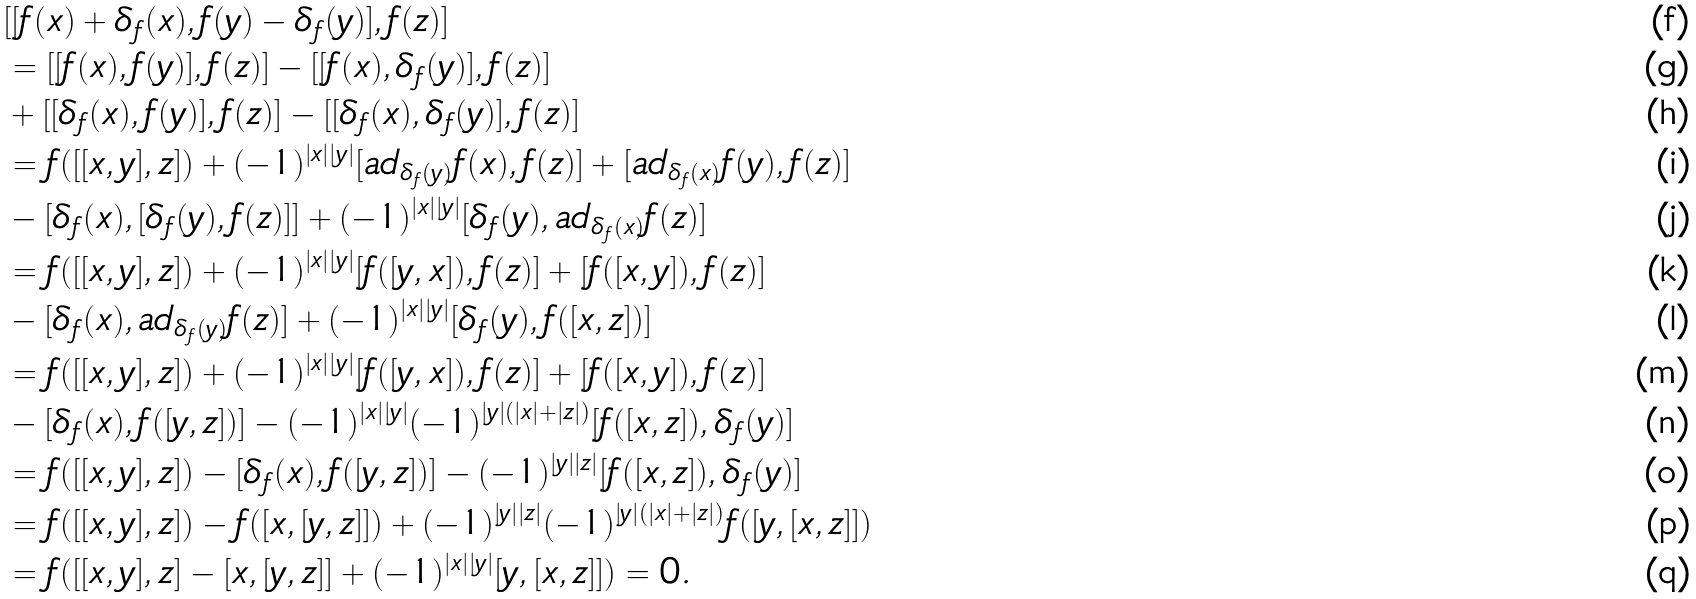<formula> <loc_0><loc_0><loc_500><loc_500>& [ [ f ( x ) + \delta _ { f } ( x ) , f ( y ) - \delta _ { f } ( y ) ] , f ( z ) ] \\ & = [ [ f ( x ) , f ( y ) ] , f ( z ) ] - [ [ f ( x ) , \delta _ { f } ( y ) ] , f ( z ) ] \\ & + [ [ \delta _ { f } ( x ) , f ( y ) ] , f ( z ) ] - [ [ \delta _ { f } ( x ) , \delta _ { f } ( y ) ] , f ( z ) ] \\ & = f ( [ [ x , y ] , z ] ) + ( - 1 ) ^ { \left | x \right | \left | y \right | } [ a d _ { \delta _ { f } ( y ) } f ( x ) , f ( z ) ] + [ a d _ { \delta _ { f } ( x ) } f ( y ) , f ( z ) ] \\ & - [ \delta _ { f } ( x ) , [ \delta _ { f } ( y ) , f ( z ) ] ] + ( - 1 ) ^ { \left | x \right | \left | y \right | } [ \delta _ { f } ( y ) , a d _ { \delta _ { f } ( x ) } f ( z ) ] \\ & = f ( [ [ x , y ] , z ] ) + ( - 1 ) ^ { \left | x \right | \left | y \right | } [ f ( [ y , x ] ) , f ( z ) ] + [ f ( [ x , y ] ) , f ( z ) ] \\ & - [ \delta _ { f } ( x ) , a d _ { \delta _ { f } ( y ) } f ( z ) ] + ( - 1 ) ^ { \left | x \right | \left | y \right | } [ \delta _ { f } ( y ) , f ( [ x , z ] ) ] \\ & = f ( [ [ x , y ] , z ] ) + ( - 1 ) ^ { \left | x \right | \left | y \right | } [ f ( [ y , x ] ) , f ( z ) ] + [ f ( [ x , y ] ) , f ( z ) ] \\ & - [ \delta _ { f } ( x ) , f ( [ y , z ] ) ] - ( - 1 ) ^ { \left | x \right | \left | y \right | } ( - 1 ) ^ { \left | y \right | ( \left | x \right | + \left | z \right | ) } [ f ( [ x , z ] ) , \delta _ { f } ( y ) ] \\ & = f ( [ [ x , y ] , z ] ) - [ \delta _ { f } ( x ) , f ( [ y , z ] ) ] - ( - 1 ) ^ { \left | y \right | \left | z \right | } [ f ( [ x , z ] ) , \delta _ { f } ( y ) ] \\ & = f ( [ [ x , y ] , z ] ) - f ( [ x , [ y , z ] ] ) + ( - 1 ) ^ { \left | y \right | \left | z \right | } ( - 1 ) ^ { \left | y \right | ( \left | x \right | + \left | z \right | ) } f ( [ y , [ x , z ] ] ) \\ & = f ( [ [ x , y ] , z ] - [ x , [ y , z ] ] + ( - 1 ) ^ { \left | x \right | \left | y \right | } [ y , [ x , z ] ] ) = 0 .</formula> 